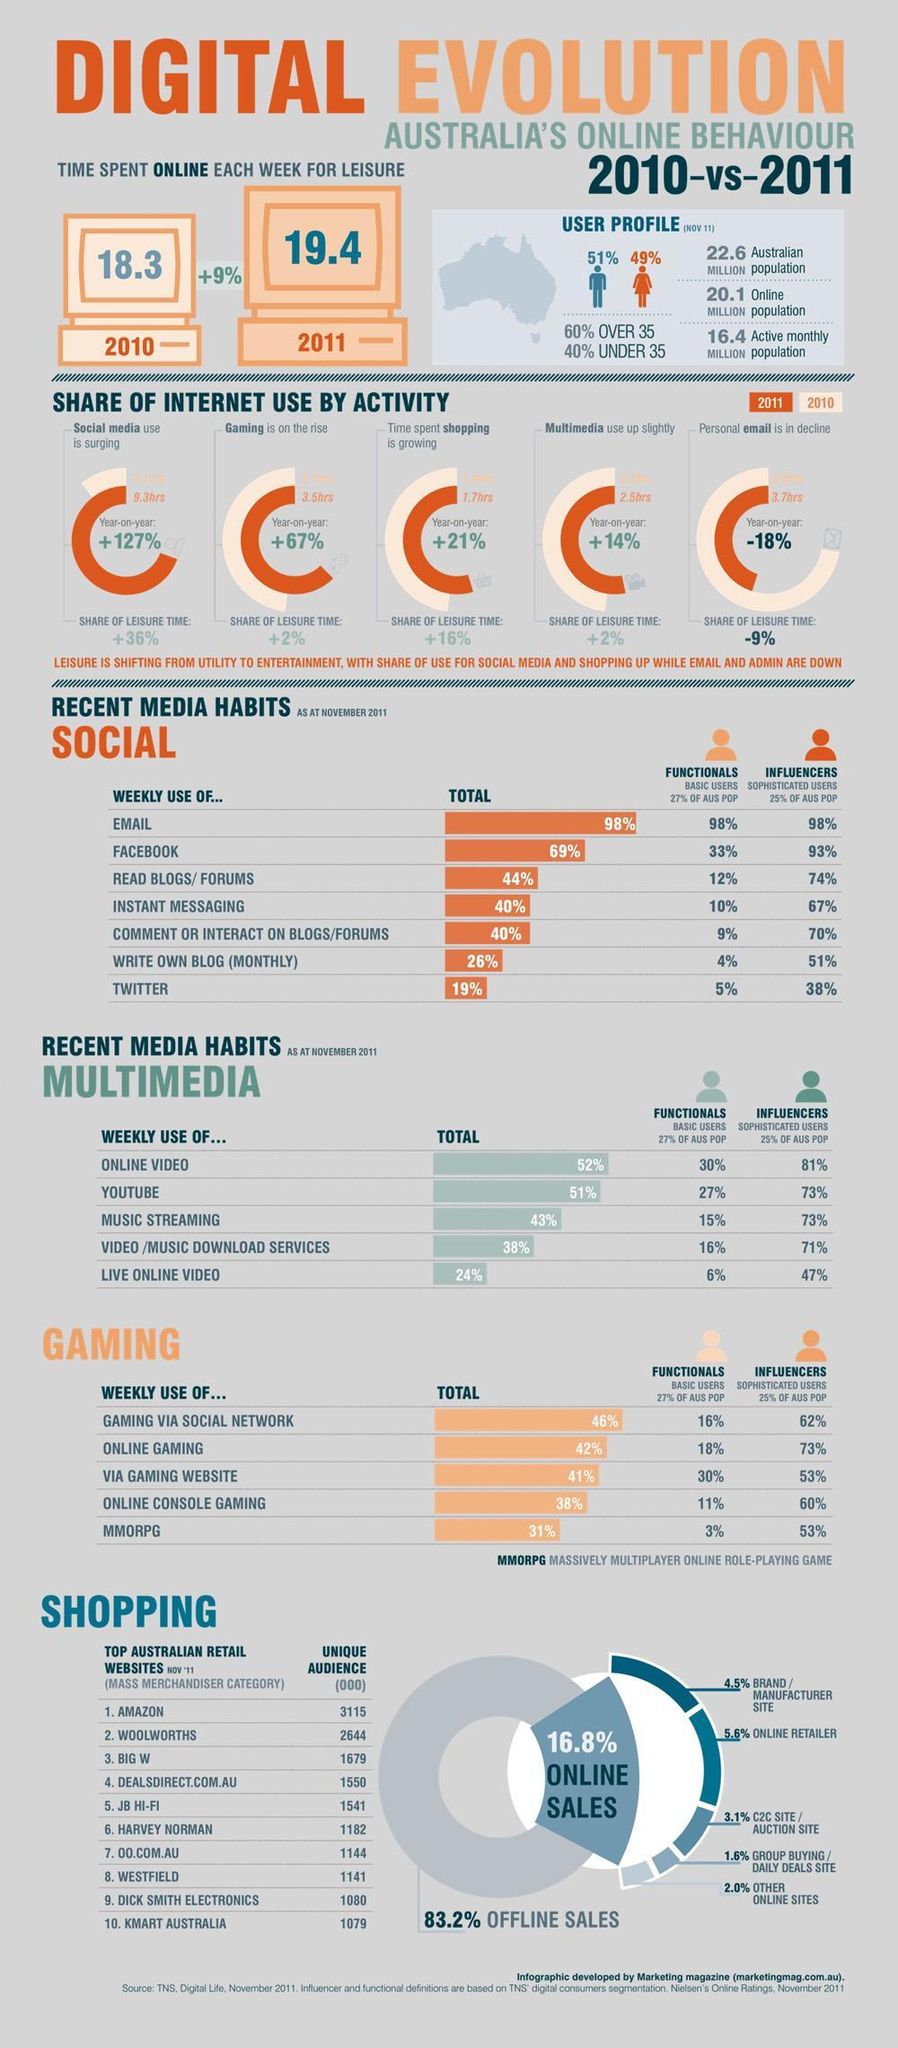How much time Australians spent in Online Shopping in the year 2011?
Answer the question with a short phrase. 1.7hrs How many more audience are there for the top Australian shopping website than the second one? 471 Which type of Gaming has third most position among Australians on a weekly usage? Via Gaming Website What percentage of Female Australians have their account in Internet? 49% What percentage of sales in Australia are not online? 83.2% What percentage of Australian Male user profiles have been created in Internet? 51% How much time Australians spent in Online Games in the year 2011? 3.5hrs Which multi media ranks second position among Australians on weekly use? YouTube Which social media ranks second position among Australians on weekly use? Facebook How much free time was spent online by Australians in 2011?. 19.4 